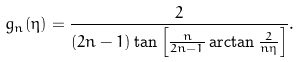<formula> <loc_0><loc_0><loc_500><loc_500>g _ { n } ( \eta ) = \frac { 2 } { ( 2 n - 1 ) \tan \left [ \frac { n } { 2 n - 1 } \arctan \frac { 2 } { n \eta } \right ] } .</formula> 